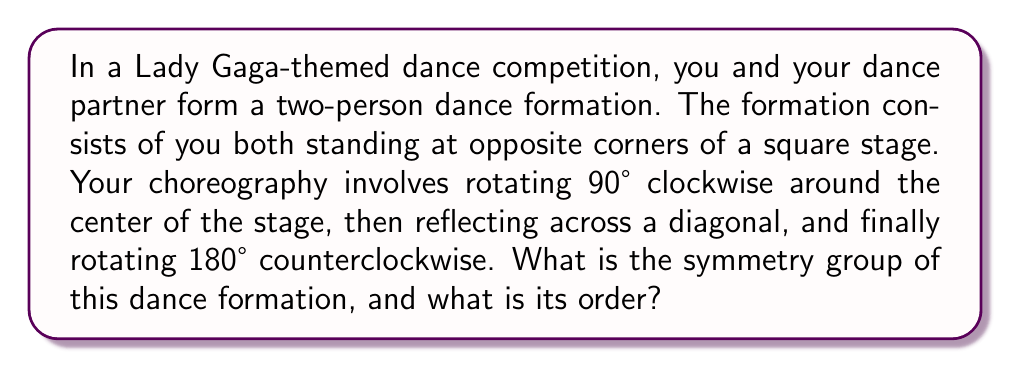Can you answer this question? Let's approach this step-by-step:

1) First, we need to identify the symmetries of the initial formation. The two dancers at opposite corners of a square have the following symmetries:
   - Identity (E)
   - 180° rotation (R²)
   - Two reflections across diagonals (D₁ and D₂)

2) These symmetries form the Klein four-group, also known as $V_4$ or $C_2 \times C_2$.

3) Now, let's consider the choreography:
   a) 90° clockwise rotation: This can be represented as R
   b) Reflection across a diagonal: This is either D₁ or D₂, let's say D₁
   c) 180° counterclockwise rotation: This is R²

4) The sequence of these moves can be represented as: $R² \circ D₁ \circ R$

5) We need to determine if this sequence generates any new symmetries. Let's calculate:
   $R² \circ D₁ \circ R = R² \circ (D₁ \circ R) = R² \circ (R³ \circ D₁) = R \circ D₁$

6) This result, $R \circ D₁$, is a new symmetry not in the original group. It represents a 90° rotation followed by a diagonal reflection.

7) With this new symmetry, we can generate all the symmetries of a square, which form the dihedral group $D_4$. This group includes:
   - Identity (E)
   - Rotations by 0°, 90°, 180°, 270° (E, R, R², R³)
   - Reflections across diagonals and midlines (D₁, D₂, M₁, M₂)

8) The order of the dihedral group $D_4$ is 8.

Therefore, the symmetry group of this dance formation is the dihedral group $D_4$, which has order 8.
Answer: $D_4$, order 8 